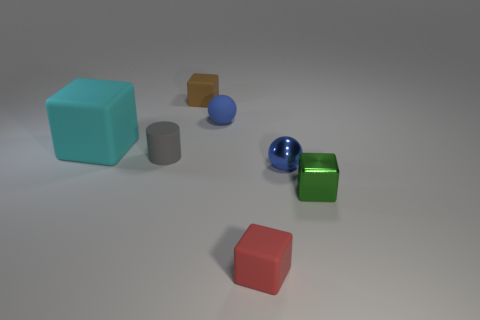Do the matte ball and the gray matte thing have the same size?
Provide a short and direct response. Yes. There is a blue sphere that is on the left side of the ball in front of the big cyan matte thing; what is its size?
Offer a very short reply. Small. What number of cubes are either big cyan things or purple objects?
Your response must be concise. 1. There is a metallic sphere; is it the same size as the block that is to the left of the small matte cylinder?
Ensure brevity in your answer.  No. Is the number of red objects behind the tiny matte cylinder greater than the number of large cyan rubber things?
Offer a very short reply. No. What size is the blue thing that is made of the same material as the brown object?
Offer a terse response. Small. Is there a shiny object that has the same color as the tiny rubber ball?
Give a very brief answer. Yes. What number of objects are either small brown matte blocks or tiny things that are on the right side of the small gray cylinder?
Ensure brevity in your answer.  5. Is the number of small red matte cylinders greater than the number of tiny green metal objects?
Keep it short and to the point. No. There is a object that is the same color as the matte sphere; what size is it?
Your answer should be very brief. Small. 